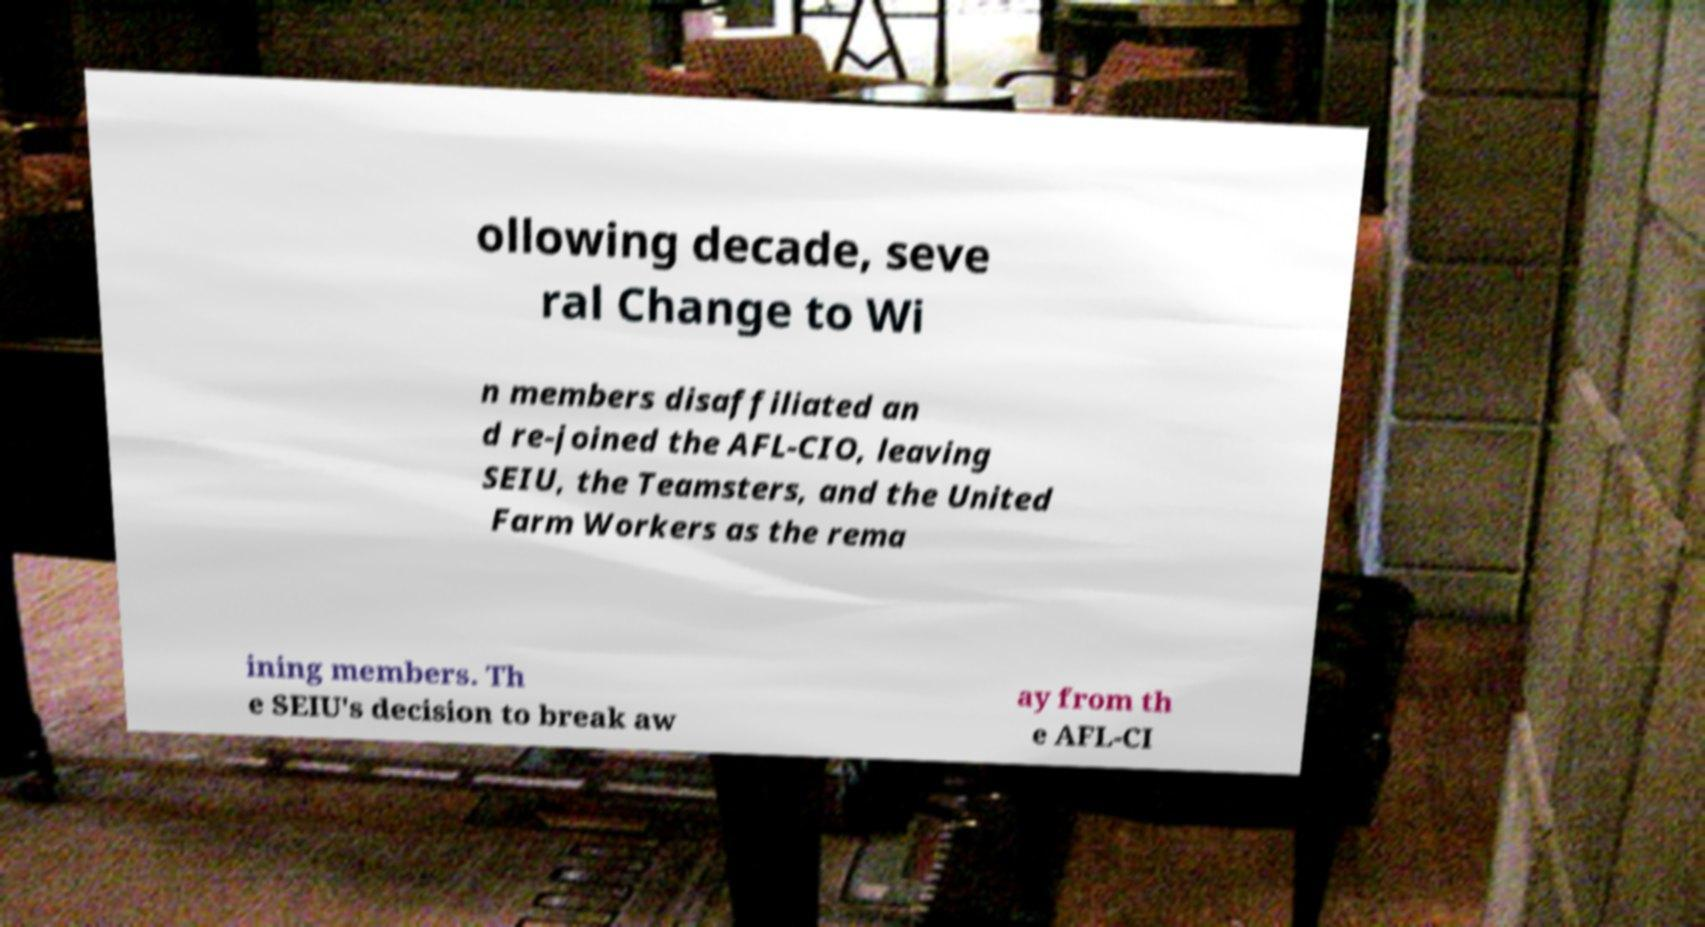I need the written content from this picture converted into text. Can you do that? ollowing decade, seve ral Change to Wi n members disaffiliated an d re-joined the AFL-CIO, leaving SEIU, the Teamsters, and the United Farm Workers as the rema ining members. Th e SEIU's decision to break aw ay from th e AFL-CI 